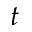<formula> <loc_0><loc_0><loc_500><loc_500>t</formula> 